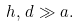Convert formula to latex. <formula><loc_0><loc_0><loc_500><loc_500>h , \, d \gg a .</formula> 